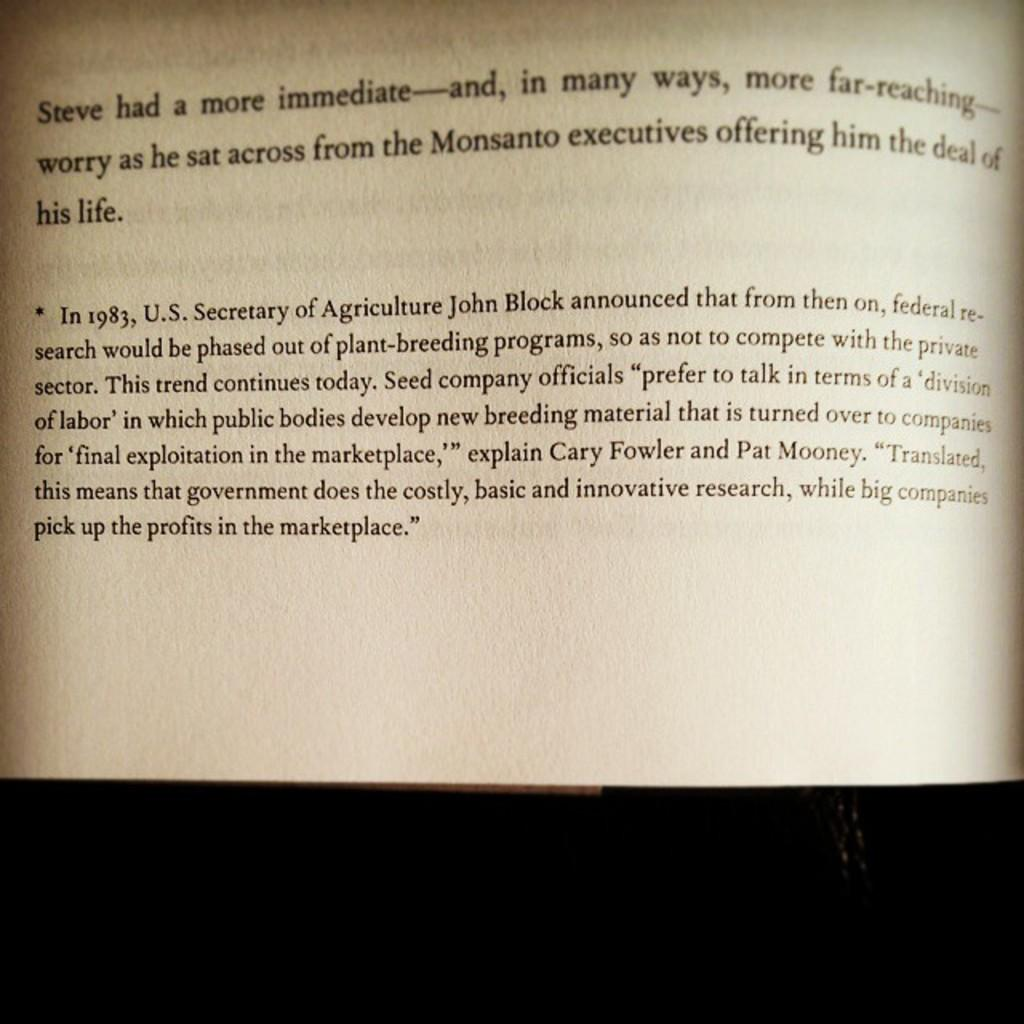<image>
Give a short and clear explanation of the subsequent image. An open book with a sentence that starts with Steve 